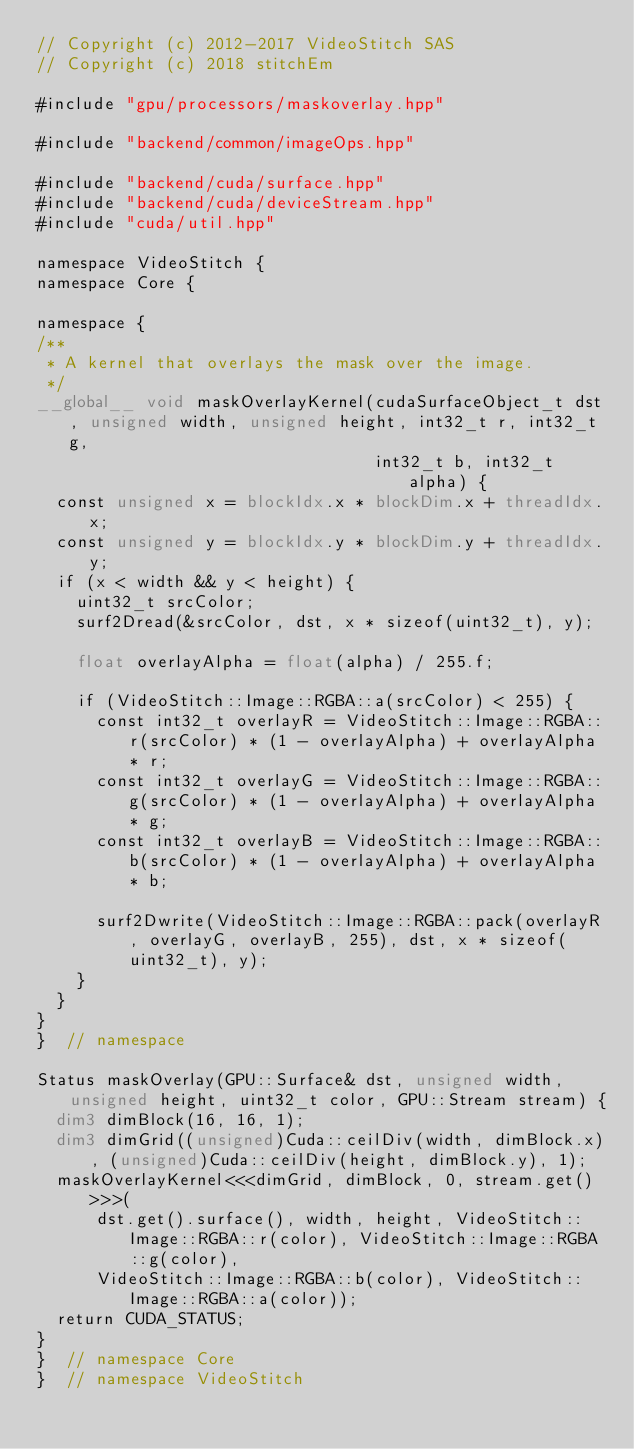Convert code to text. <code><loc_0><loc_0><loc_500><loc_500><_Cuda_>// Copyright (c) 2012-2017 VideoStitch SAS
// Copyright (c) 2018 stitchEm

#include "gpu/processors/maskoverlay.hpp"

#include "backend/common/imageOps.hpp"

#include "backend/cuda/surface.hpp"
#include "backend/cuda/deviceStream.hpp"
#include "cuda/util.hpp"

namespace VideoStitch {
namespace Core {

namespace {
/**
 * A kernel that overlays the mask over the image.
 */
__global__ void maskOverlayKernel(cudaSurfaceObject_t dst, unsigned width, unsigned height, int32_t r, int32_t g,
                                  int32_t b, int32_t alpha) {
  const unsigned x = blockIdx.x * blockDim.x + threadIdx.x;
  const unsigned y = blockIdx.y * blockDim.y + threadIdx.y;
  if (x < width && y < height) {
    uint32_t srcColor;
    surf2Dread(&srcColor, dst, x * sizeof(uint32_t), y);

    float overlayAlpha = float(alpha) / 255.f;

    if (VideoStitch::Image::RGBA::a(srcColor) < 255) {
      const int32_t overlayR = VideoStitch::Image::RGBA::r(srcColor) * (1 - overlayAlpha) + overlayAlpha * r;
      const int32_t overlayG = VideoStitch::Image::RGBA::g(srcColor) * (1 - overlayAlpha) + overlayAlpha * g;
      const int32_t overlayB = VideoStitch::Image::RGBA::b(srcColor) * (1 - overlayAlpha) + overlayAlpha * b;

      surf2Dwrite(VideoStitch::Image::RGBA::pack(overlayR, overlayG, overlayB, 255), dst, x * sizeof(uint32_t), y);
    }
  }
}
}  // namespace

Status maskOverlay(GPU::Surface& dst, unsigned width, unsigned height, uint32_t color, GPU::Stream stream) {
  dim3 dimBlock(16, 16, 1);
  dim3 dimGrid((unsigned)Cuda::ceilDiv(width, dimBlock.x), (unsigned)Cuda::ceilDiv(height, dimBlock.y), 1);
  maskOverlayKernel<<<dimGrid, dimBlock, 0, stream.get()>>>(
      dst.get().surface(), width, height, VideoStitch::Image::RGBA::r(color), VideoStitch::Image::RGBA::g(color),
      VideoStitch::Image::RGBA::b(color), VideoStitch::Image::RGBA::a(color));
  return CUDA_STATUS;
}
}  // namespace Core
}  // namespace VideoStitch
</code> 